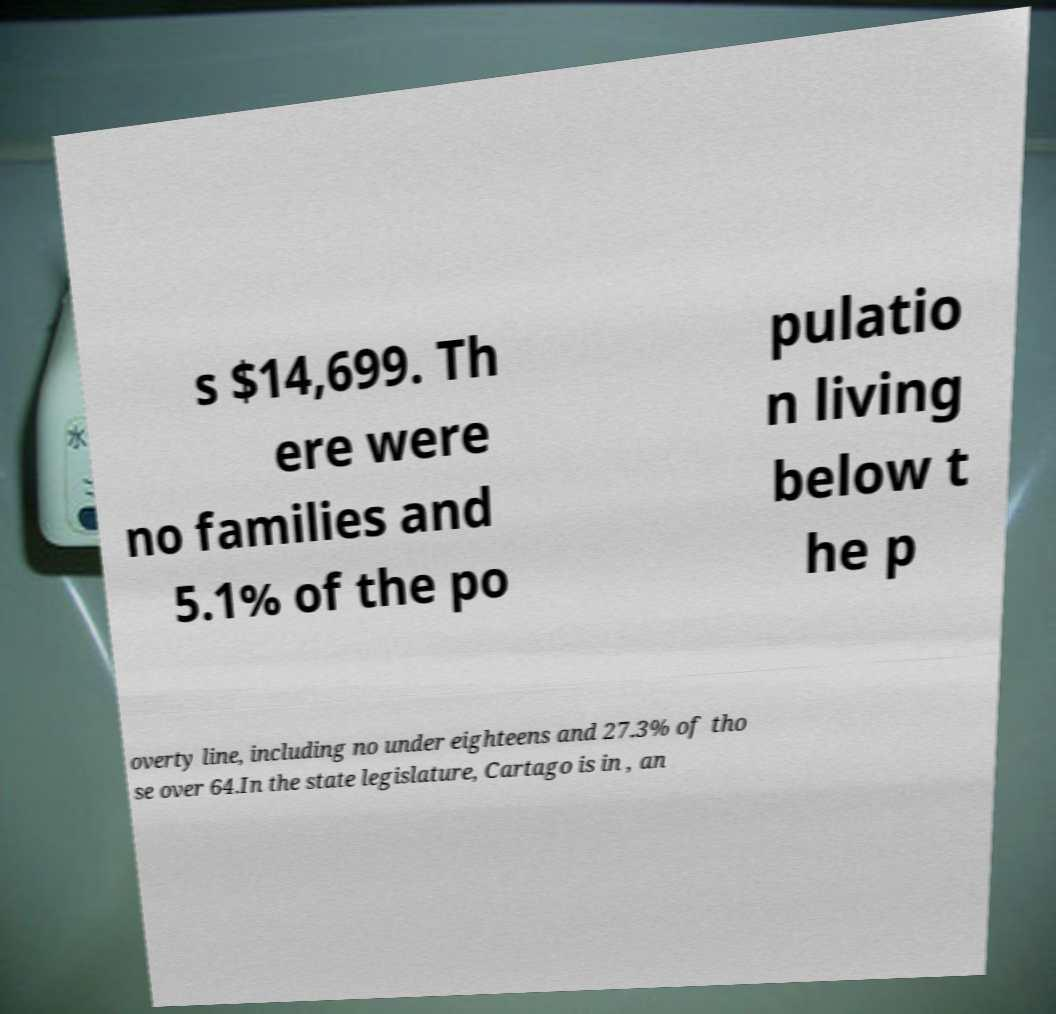Please read and relay the text visible in this image. What does it say? s $14,699. Th ere were no families and 5.1% of the po pulatio n living below t he p overty line, including no under eighteens and 27.3% of tho se over 64.In the state legislature, Cartago is in , an 